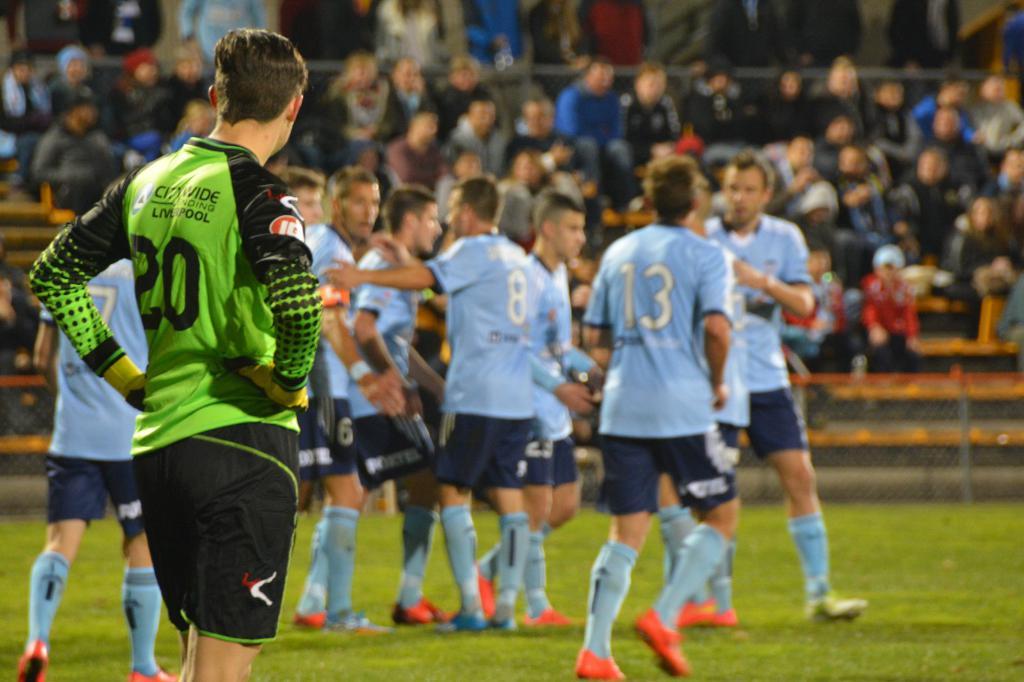What number is the person in the green jersey?
Provide a short and direct response. 20. 